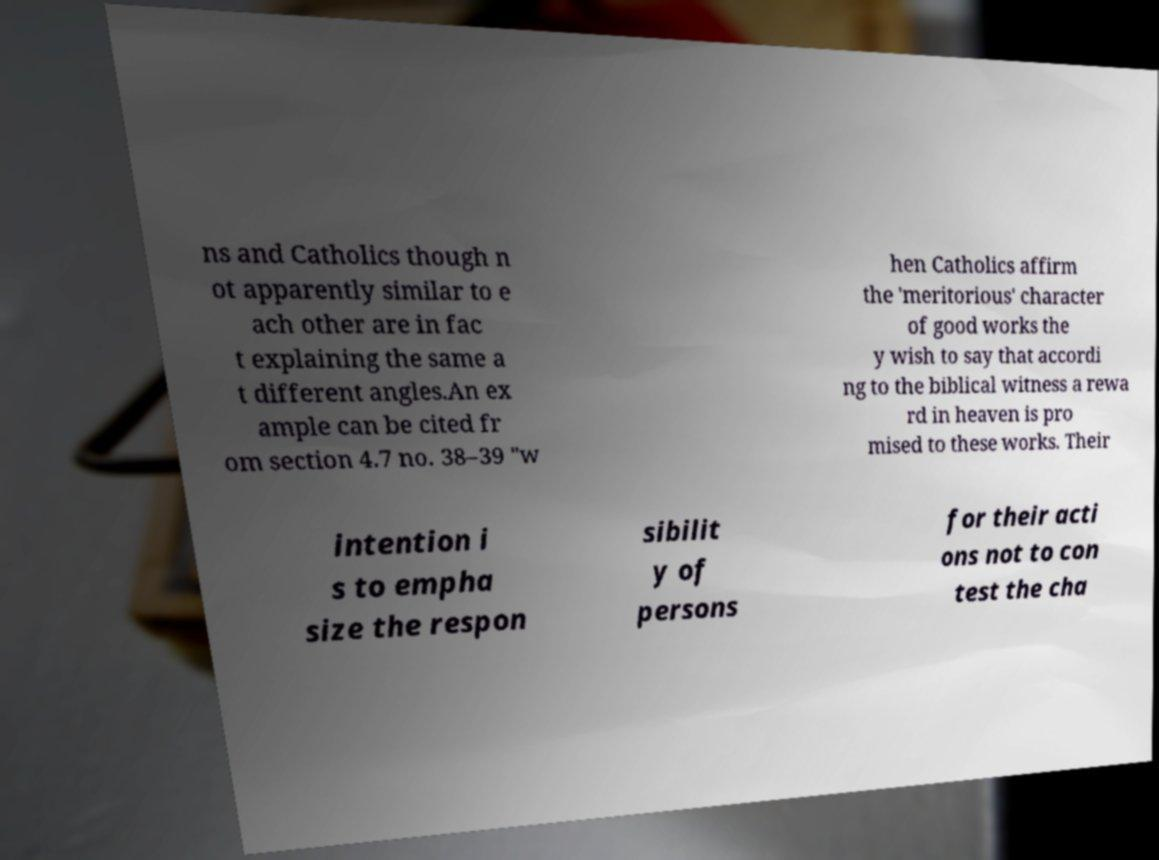Can you accurately transcribe the text from the provided image for me? ns and Catholics though n ot apparently similar to e ach other are in fac t explaining the same a t different angles.An ex ample can be cited fr om section 4.7 no. 38–39 "w hen Catholics affirm the 'meritorious' character of good works the y wish to say that accordi ng to the biblical witness a rewa rd in heaven is pro mised to these works. Their intention i s to empha size the respon sibilit y of persons for their acti ons not to con test the cha 